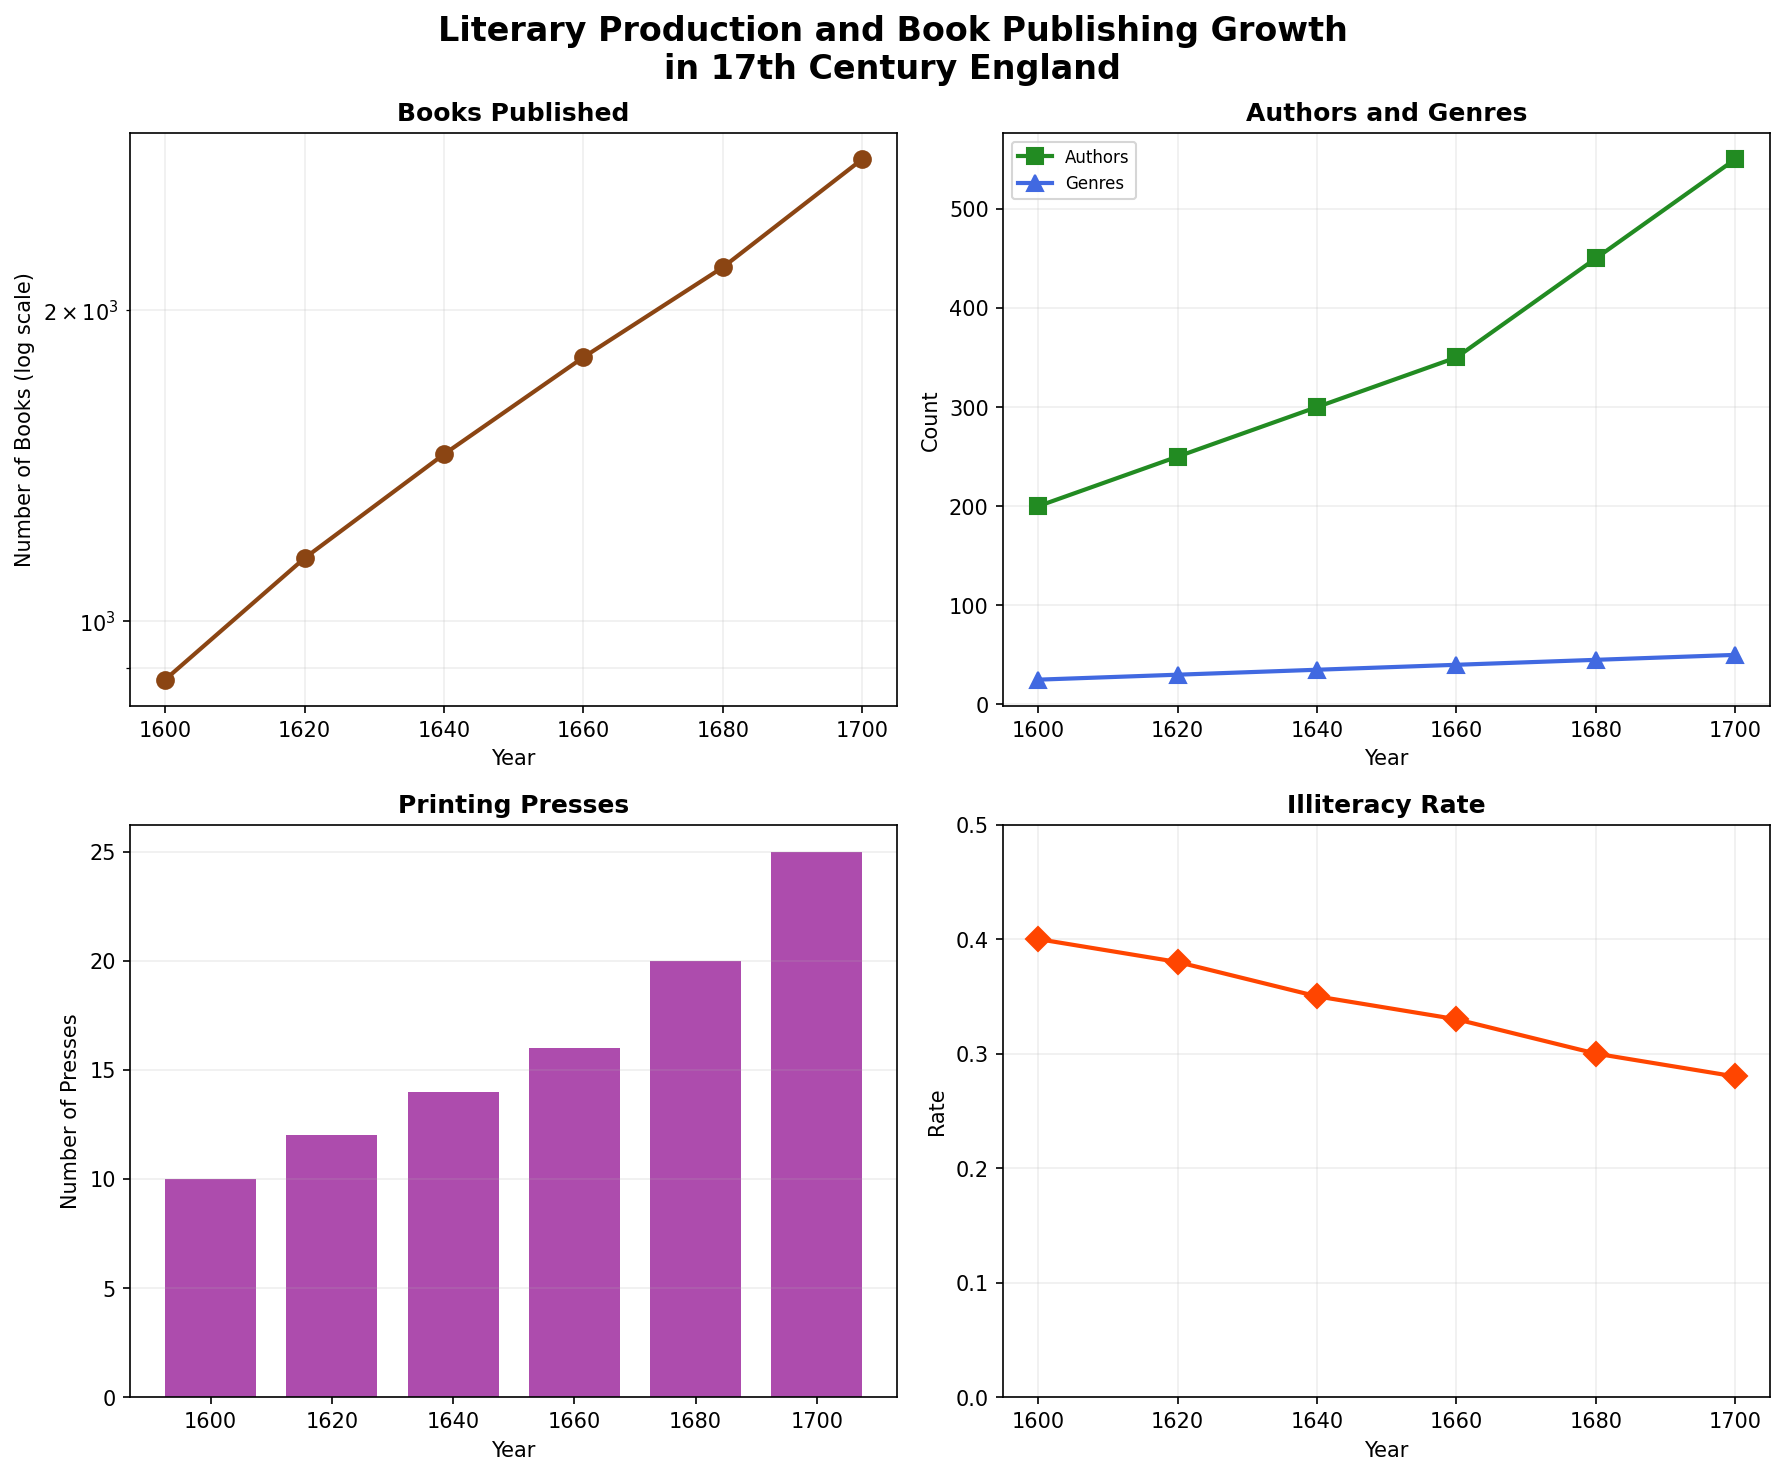What's the title of the figure? The title is displayed prominently at the top of the figure, summarizing the subject of the plots. It reads 'Literary Production and Book Publishing Growth in 17th Century England'.
Answer: Literary Production and Book Publishing Growth in 17th Century England How many subplots are in the figure? The figure is divided into a 2x2 grid of subplots. This is visually apparent because there are four separate plots arranged in rows and columns.
Answer: 4 Which plot shows data on Printing Presses over the years? The subplot titled 'Printing Presses' shows this data. The title is clearly labeled in the figure.
Answer: Bottom-left plot What is the trend in the number of books published between 1600 and 1700? The number of books published, shown on a semilogarithmic scale, increases significantly from 877 in 1600 to 2800 in 1700.
Answer: Increasing By how much did the number of authors increase from 1600 to 1700? The authors plot shows authors increasing from 200 in 1600 to 550 in 1700. The difference is calculated as 550 - 200.
Answer: 350 Which plot uses a log scale for its y-axis? The first subplot, titled 'Books Published,' uses a semilogarithmic scale on the y-axis, as indicated by the log scale units and the vertical axis label 'Number of Books (log scale)'.
Answer: Top-left plot What is the illiteracy rate in 1680 compared to 1700? The illiteracy rate is shown in the bottom-right plot. In 1680, it is 0.30, and in 1700 it is 0.28. The rate decreases from 0.30 to 0.28.
Answer: Decreased What are the markers used for genres in the 'Authors and Genres' plot? The 'Authors and Genres' plot uses a different marker for each dataset. The marker for genres is a triangle (‘^’). This is identified by looking at the shape of the points plotted for genres.
Answer: Triangle Which year shows a notable increase in both the number of authors and genres? Observing the 'Authors and Genres' plot, both lines show notable increases between 1660 and 1680.
Answer: Between 1660 and 1680 Estimate the average number of Printing Presses from 1600 to 1700. To find the average, add the values from 1600 to 1700 and divide by the number of years: (10+12+14+16+20+25)/6 = 16.1667.
Answer: Approximately 16 